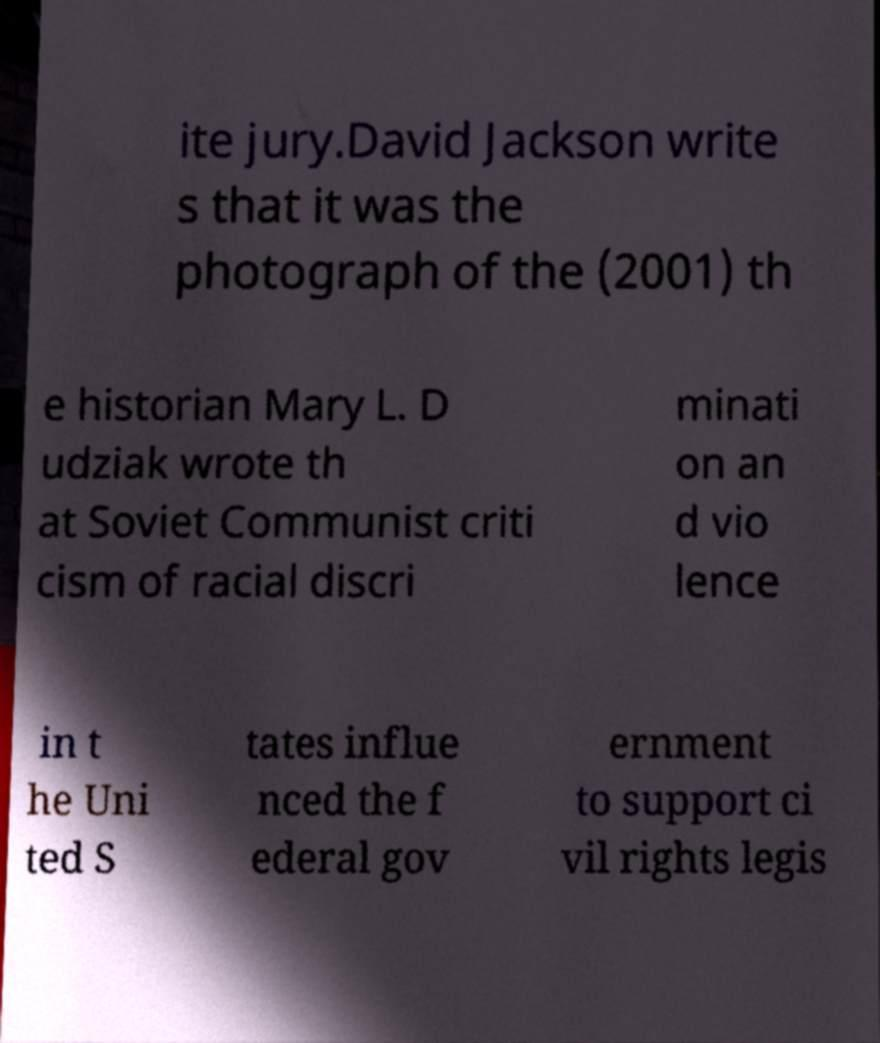Please read and relay the text visible in this image. What does it say? ite jury.David Jackson write s that it was the photograph of the (2001) th e historian Mary L. D udziak wrote th at Soviet Communist criti cism of racial discri minati on an d vio lence in t he Uni ted S tates influe nced the f ederal gov ernment to support ci vil rights legis 